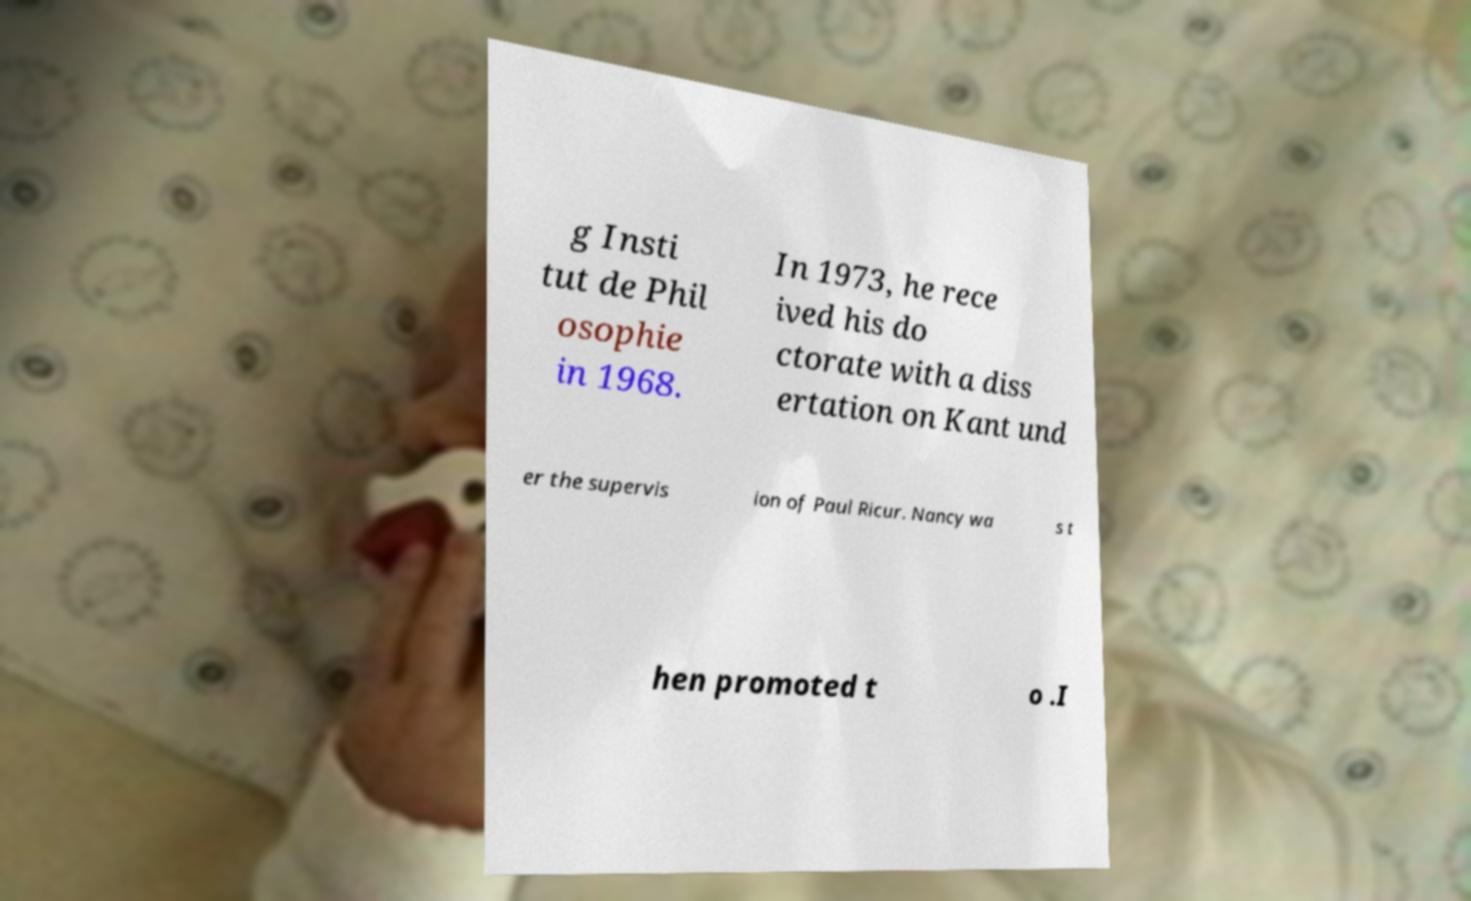I need the written content from this picture converted into text. Can you do that? g Insti tut de Phil osophie in 1968. In 1973, he rece ived his do ctorate with a diss ertation on Kant und er the supervis ion of Paul Ricur. Nancy wa s t hen promoted t o .I 